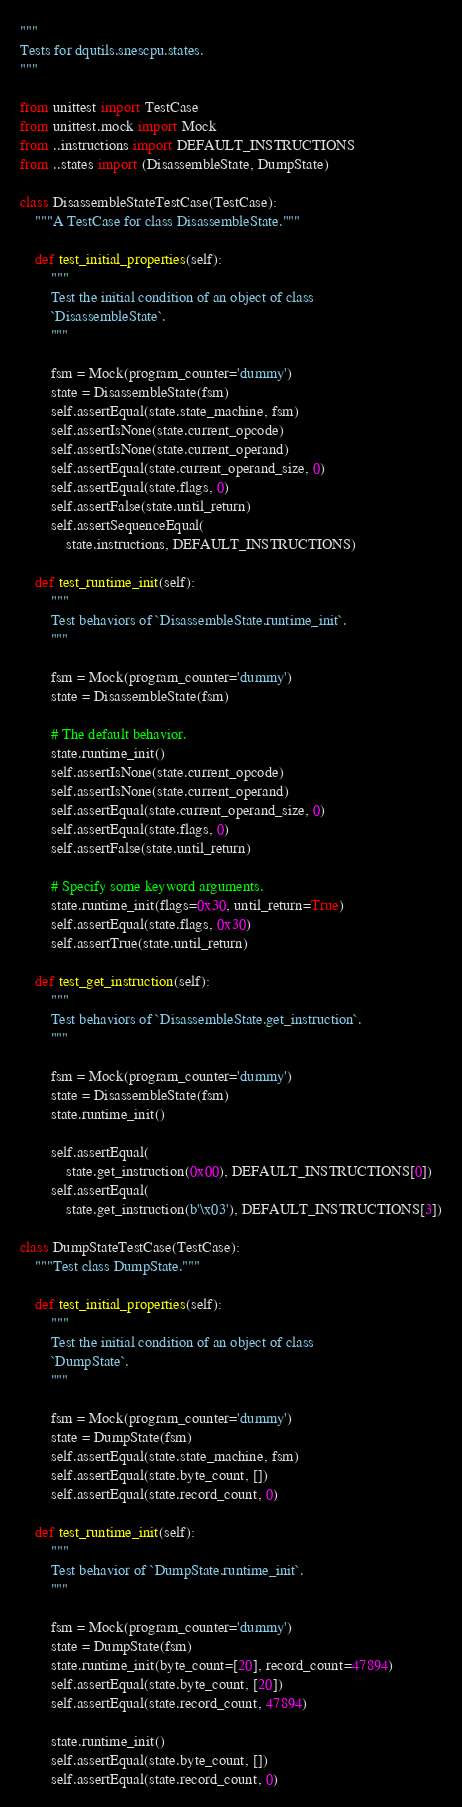<code> <loc_0><loc_0><loc_500><loc_500><_Python_>"""
Tests for dqutils.snescpu.states.
"""

from unittest import TestCase
from unittest.mock import Mock
from ..instructions import DEFAULT_INSTRUCTIONS
from ..states import (DisassembleState, DumpState)

class DisassembleStateTestCase(TestCase):
    """A TestCase for class DisassembleState."""

    def test_initial_properties(self):
        """
        Test the initial condition of an object of class
        `DisassembleState`.
        """

        fsm = Mock(program_counter='dummy')
        state = DisassembleState(fsm)
        self.assertEqual(state.state_machine, fsm)
        self.assertIsNone(state.current_opcode)
        self.assertIsNone(state.current_operand)
        self.assertEqual(state.current_operand_size, 0)
        self.assertEqual(state.flags, 0)
        self.assertFalse(state.until_return)
        self.assertSequenceEqual(
            state.instructions, DEFAULT_INSTRUCTIONS)

    def test_runtime_init(self):
        """
        Test behaviors of `DisassembleState.runtime_init`. 
        """

        fsm = Mock(program_counter='dummy')
        state = DisassembleState(fsm)

        # The default behavior.
        state.runtime_init()
        self.assertIsNone(state.current_opcode)
        self.assertIsNone(state.current_operand)
        self.assertEqual(state.current_operand_size, 0)
        self.assertEqual(state.flags, 0)
        self.assertFalse(state.until_return)

        # Specify some keyword arguments.
        state.runtime_init(flags=0x30, until_return=True)
        self.assertEqual(state.flags, 0x30)
        self.assertTrue(state.until_return)

    def test_get_instruction(self):
        """
        Test behaviors of `DisassembleState.get_instruction`.
        """

        fsm = Mock(program_counter='dummy')
        state = DisassembleState(fsm)
        state.runtime_init()

        self.assertEqual(
            state.get_instruction(0x00), DEFAULT_INSTRUCTIONS[0])
        self.assertEqual(
            state.get_instruction(b'\x03'), DEFAULT_INSTRUCTIONS[3])

class DumpStateTestCase(TestCase):
    """Test class DumpState."""

    def test_initial_properties(self):
        """
        Test the initial condition of an object of class
        `DumpState`.
        """

        fsm = Mock(program_counter='dummy')
        state = DumpState(fsm)
        self.assertEqual(state.state_machine, fsm)
        self.assertEqual(state.byte_count, [])
        self.assertEqual(state.record_count, 0)

    def test_runtime_init(self):
        """
        Test behavior of `DumpState.runtime_init`. 
        """

        fsm = Mock(program_counter='dummy')
        state = DumpState(fsm)
        state.runtime_init(byte_count=[20], record_count=47894)
        self.assertEqual(state.byte_count, [20])
        self.assertEqual(state.record_count, 47894)

        state.runtime_init()
        self.assertEqual(state.byte_count, [])
        self.assertEqual(state.record_count, 0)
</code> 